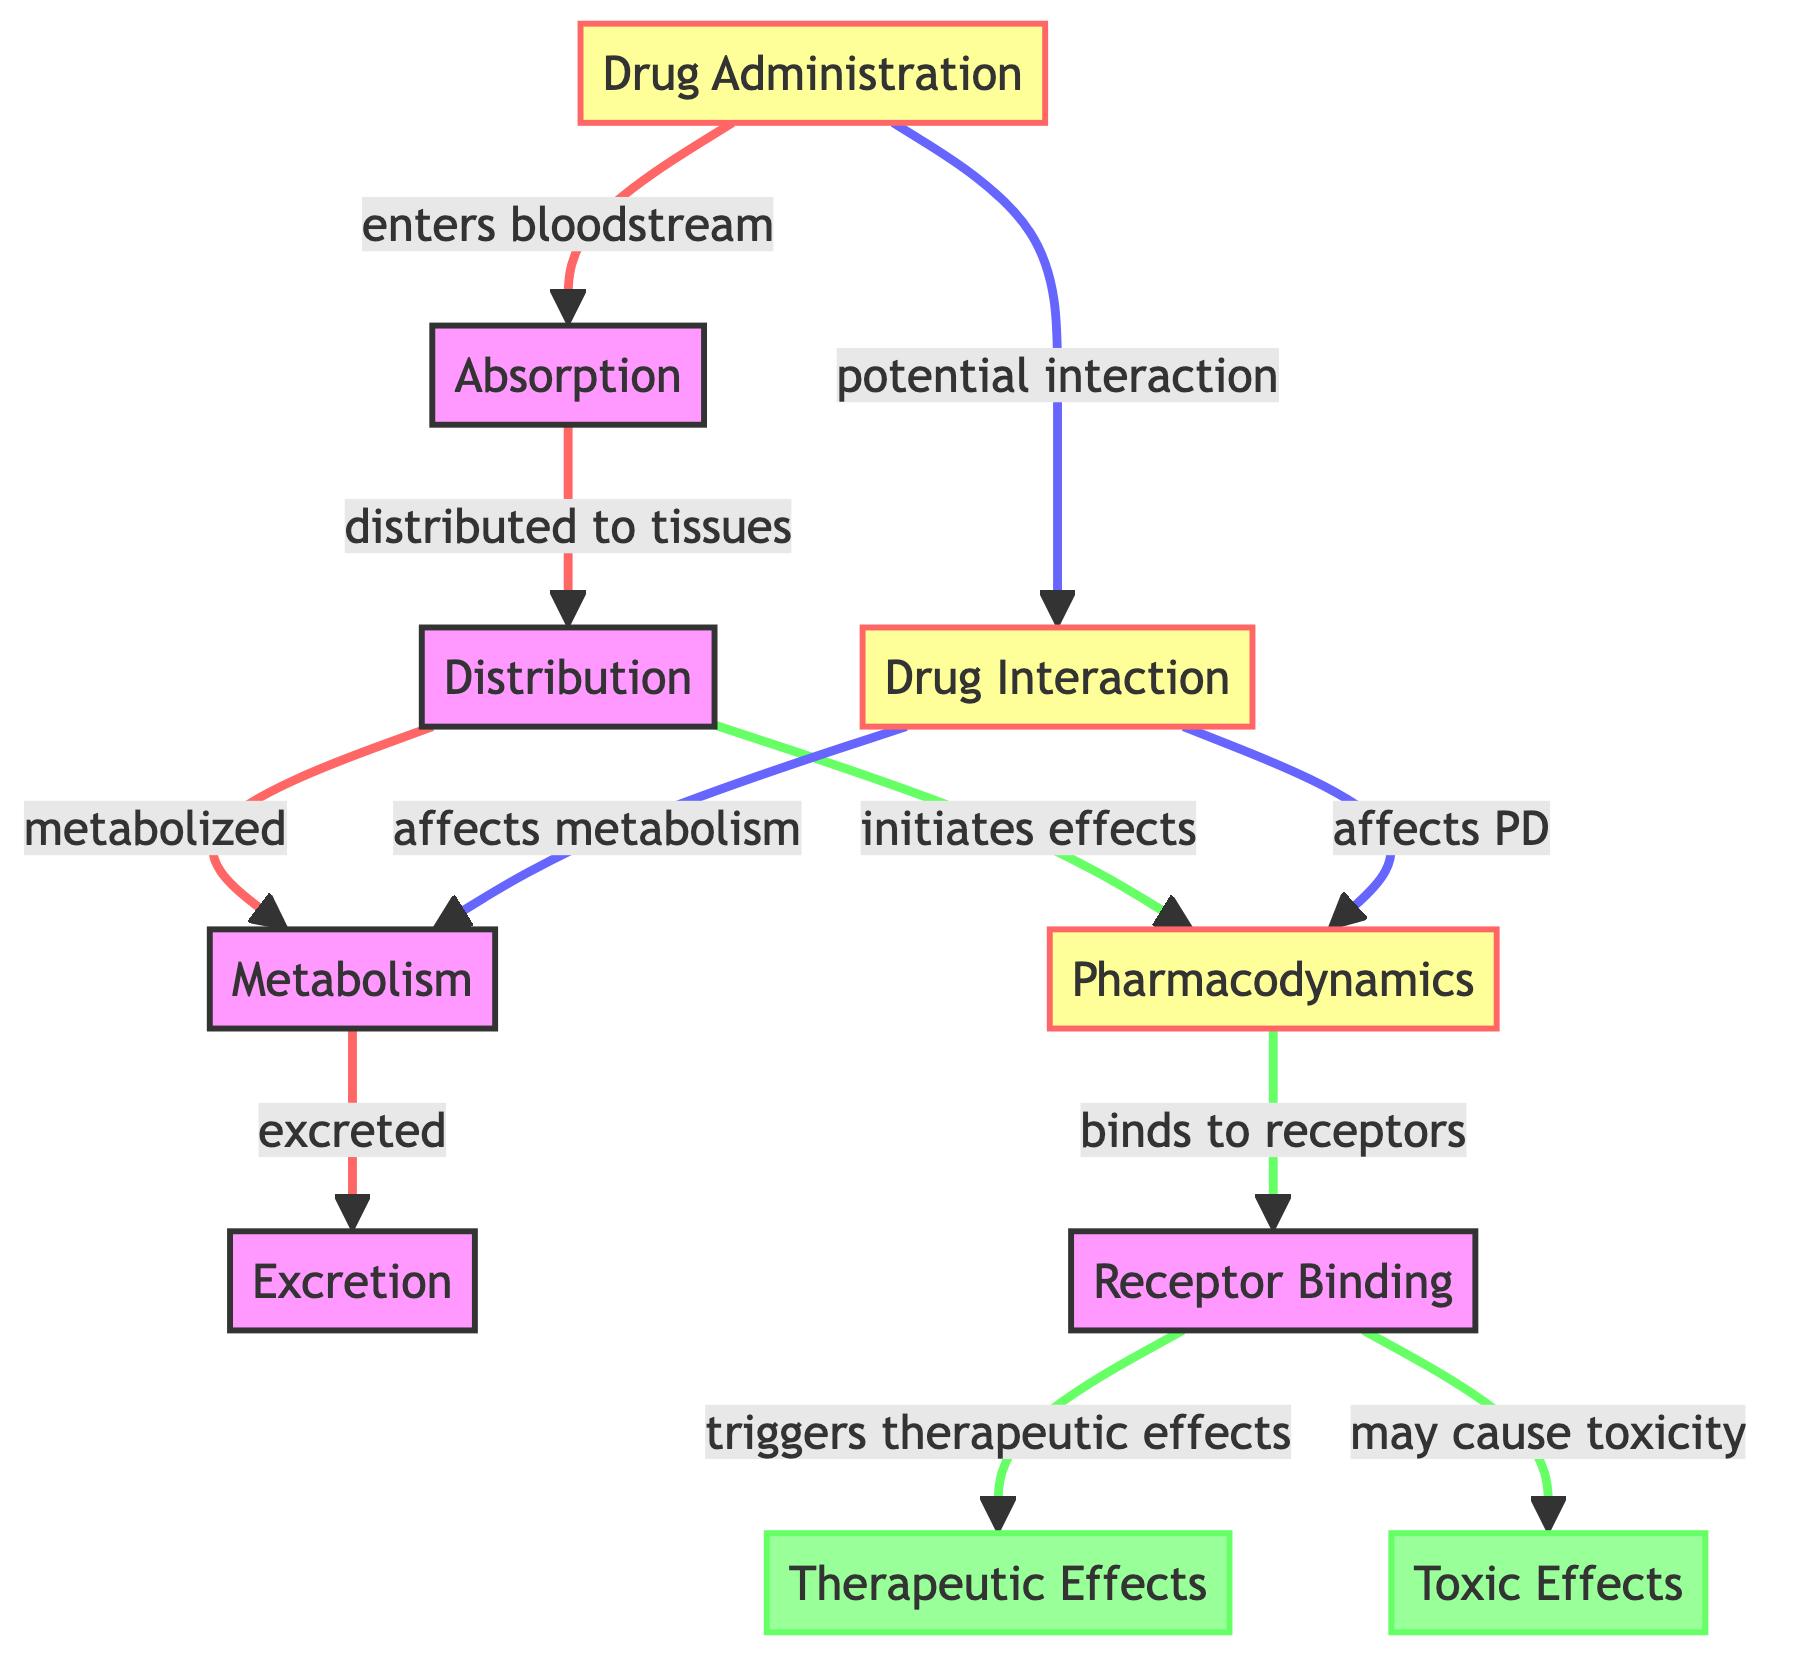What is the first step after drug administration? The diagram shows that after "Drug Administration," the first step is "Absorption," which is directly connected to the drug administration node.
Answer: Absorption How many therapeutic effects are triggered by receptor binding? According to the diagram, "Receptor Binding" leads to one outcome, which is "Therapeutic Effects." There are no alternative outcomes listed for this connection.
Answer: One What does drug interaction affect in the pharmacokinetics model? The diagram shows that "Drug Interaction" affects both "Pharmacodynamics" and "Metabolism," as these nodes are connected to the drug interaction node.
Answer: Pharmacodynamics and Metabolism Which node represents toxic effects? The diagram specifically labels the node "Toxic Effects" under the pharmacodynamics section, indicating its importance in representing adverse reactions.
Answer: Toxic Effects How many nodes are linked to the pharmacodynamics node? By analyzing the connections from the "Pharmacodynamics" node, we see that it links to "Receptor Binding," which in turn connects to "Therapeutic Effects" and "Toxic Effects," totaling three linked nodes.
Answer: Three What is the relationship between absorption and distribution? The diagram illustrates that "Absorption" is followed by "Distribution," indicating that drugs are dispersed to tissues after absorption, establishing a clear sequential relationship.
Answer: Distributed to tissues How are metabolic processes characterized in the diagram? The diagram portrays "Metabolism" as a direct result of "Distribution," establishing that before drugs are metabolized, they must first be distributed throughout the body.
Answer: Metabolized Name the node that initiates effects after distribution. According to the diagram, "Distribution" leads directly to "Pharmacodynamics," meaning it is the node responsible for initiating the drug's effects.
Answer: Pharmacodynamics What evident effect does drug administration have? The diagram clearly indicates that "Drug Administration" leads to "Drug Interaction," suggesting that the initial administration can lead to potential interactions with other drugs.
Answer: Potential interaction 